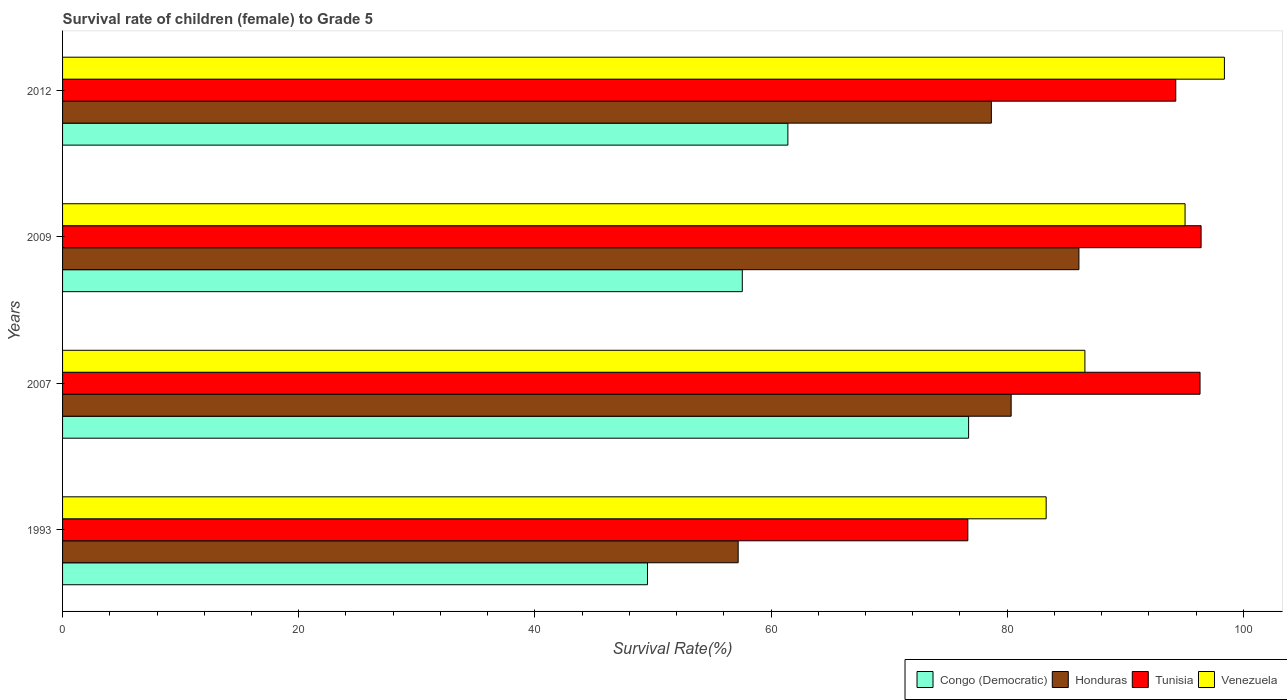How many bars are there on the 4th tick from the top?
Offer a very short reply. 4. What is the survival rate of female children to grade 5 in Venezuela in 1993?
Your response must be concise. 83.3. Across all years, what is the maximum survival rate of female children to grade 5 in Congo (Democratic)?
Ensure brevity in your answer.  76.73. Across all years, what is the minimum survival rate of female children to grade 5 in Tunisia?
Offer a very short reply. 76.67. In which year was the survival rate of female children to grade 5 in Congo (Democratic) minimum?
Ensure brevity in your answer.  1993. What is the total survival rate of female children to grade 5 in Tunisia in the graph?
Provide a succinct answer. 363.7. What is the difference between the survival rate of female children to grade 5 in Tunisia in 1993 and that in 2009?
Your answer should be compact. -19.76. What is the difference between the survival rate of female children to grade 5 in Tunisia in 2009 and the survival rate of female children to grade 5 in Venezuela in 2007?
Make the answer very short. 9.84. What is the average survival rate of female children to grade 5 in Venezuela per year?
Make the answer very short. 90.84. In the year 2007, what is the difference between the survival rate of female children to grade 5 in Venezuela and survival rate of female children to grade 5 in Honduras?
Offer a terse response. 6.25. In how many years, is the survival rate of female children to grade 5 in Honduras greater than 52 %?
Offer a very short reply. 4. What is the ratio of the survival rate of female children to grade 5 in Congo (Democratic) in 1993 to that in 2009?
Provide a succinct answer. 0.86. Is the survival rate of female children to grade 5 in Venezuela in 2009 less than that in 2012?
Keep it short and to the point. Yes. Is the difference between the survival rate of female children to grade 5 in Venezuela in 2007 and 2012 greater than the difference between the survival rate of female children to grade 5 in Honduras in 2007 and 2012?
Provide a short and direct response. No. What is the difference between the highest and the second highest survival rate of female children to grade 5 in Venezuela?
Provide a succinct answer. 3.33. What is the difference between the highest and the lowest survival rate of female children to grade 5 in Congo (Democratic)?
Offer a very short reply. 27.2. Is the sum of the survival rate of female children to grade 5 in Venezuela in 1993 and 2012 greater than the maximum survival rate of female children to grade 5 in Honduras across all years?
Make the answer very short. Yes. What does the 1st bar from the top in 2009 represents?
Provide a short and direct response. Venezuela. What does the 2nd bar from the bottom in 2009 represents?
Provide a succinct answer. Honduras. What is the difference between two consecutive major ticks on the X-axis?
Your response must be concise. 20. Are the values on the major ticks of X-axis written in scientific E-notation?
Your answer should be very brief. No. Does the graph contain any zero values?
Keep it short and to the point. No. Does the graph contain grids?
Keep it short and to the point. No. Where does the legend appear in the graph?
Offer a terse response. Bottom right. How many legend labels are there?
Offer a very short reply. 4. How are the legend labels stacked?
Give a very brief answer. Horizontal. What is the title of the graph?
Offer a terse response. Survival rate of children (female) to Grade 5. What is the label or title of the X-axis?
Provide a succinct answer. Survival Rate(%). What is the label or title of the Y-axis?
Your answer should be compact. Years. What is the Survival Rate(%) in Congo (Democratic) in 1993?
Provide a succinct answer. 49.54. What is the Survival Rate(%) in Honduras in 1993?
Your answer should be very brief. 57.22. What is the Survival Rate(%) of Tunisia in 1993?
Keep it short and to the point. 76.67. What is the Survival Rate(%) in Venezuela in 1993?
Make the answer very short. 83.3. What is the Survival Rate(%) of Congo (Democratic) in 2007?
Provide a succinct answer. 76.73. What is the Survival Rate(%) of Honduras in 2007?
Provide a succinct answer. 80.34. What is the Survival Rate(%) in Tunisia in 2007?
Offer a very short reply. 96.33. What is the Survival Rate(%) in Venezuela in 2007?
Provide a succinct answer. 86.58. What is the Survival Rate(%) in Congo (Democratic) in 2009?
Ensure brevity in your answer.  57.57. What is the Survival Rate(%) in Honduras in 2009?
Keep it short and to the point. 86.08. What is the Survival Rate(%) in Tunisia in 2009?
Your answer should be compact. 96.42. What is the Survival Rate(%) of Venezuela in 2009?
Your response must be concise. 95.07. What is the Survival Rate(%) of Congo (Democratic) in 2012?
Keep it short and to the point. 61.43. What is the Survival Rate(%) in Honduras in 2012?
Offer a very short reply. 78.66. What is the Survival Rate(%) in Tunisia in 2012?
Offer a terse response. 94.28. What is the Survival Rate(%) in Venezuela in 2012?
Your response must be concise. 98.4. Across all years, what is the maximum Survival Rate(%) in Congo (Democratic)?
Offer a terse response. 76.73. Across all years, what is the maximum Survival Rate(%) in Honduras?
Your response must be concise. 86.08. Across all years, what is the maximum Survival Rate(%) of Tunisia?
Your response must be concise. 96.42. Across all years, what is the maximum Survival Rate(%) of Venezuela?
Your answer should be compact. 98.4. Across all years, what is the minimum Survival Rate(%) in Congo (Democratic)?
Offer a very short reply. 49.54. Across all years, what is the minimum Survival Rate(%) of Honduras?
Ensure brevity in your answer.  57.22. Across all years, what is the minimum Survival Rate(%) of Tunisia?
Give a very brief answer. 76.67. Across all years, what is the minimum Survival Rate(%) of Venezuela?
Your response must be concise. 83.3. What is the total Survival Rate(%) in Congo (Democratic) in the graph?
Your response must be concise. 245.27. What is the total Survival Rate(%) in Honduras in the graph?
Provide a succinct answer. 302.29. What is the total Survival Rate(%) in Tunisia in the graph?
Make the answer very short. 363.7. What is the total Survival Rate(%) of Venezuela in the graph?
Ensure brevity in your answer.  363.35. What is the difference between the Survival Rate(%) in Congo (Democratic) in 1993 and that in 2007?
Give a very brief answer. -27.2. What is the difference between the Survival Rate(%) in Honduras in 1993 and that in 2007?
Make the answer very short. -23.12. What is the difference between the Survival Rate(%) of Tunisia in 1993 and that in 2007?
Offer a terse response. -19.67. What is the difference between the Survival Rate(%) of Venezuela in 1993 and that in 2007?
Keep it short and to the point. -3.28. What is the difference between the Survival Rate(%) in Congo (Democratic) in 1993 and that in 2009?
Your answer should be very brief. -8.03. What is the difference between the Survival Rate(%) of Honduras in 1993 and that in 2009?
Keep it short and to the point. -28.86. What is the difference between the Survival Rate(%) in Tunisia in 1993 and that in 2009?
Keep it short and to the point. -19.76. What is the difference between the Survival Rate(%) of Venezuela in 1993 and that in 2009?
Your response must be concise. -11.76. What is the difference between the Survival Rate(%) in Congo (Democratic) in 1993 and that in 2012?
Provide a succinct answer. -11.89. What is the difference between the Survival Rate(%) in Honduras in 1993 and that in 2012?
Offer a terse response. -21.44. What is the difference between the Survival Rate(%) in Tunisia in 1993 and that in 2012?
Provide a short and direct response. -17.61. What is the difference between the Survival Rate(%) in Venezuela in 1993 and that in 2012?
Offer a terse response. -15.1. What is the difference between the Survival Rate(%) of Congo (Democratic) in 2007 and that in 2009?
Your answer should be compact. 19.17. What is the difference between the Survival Rate(%) of Honduras in 2007 and that in 2009?
Offer a very short reply. -5.74. What is the difference between the Survival Rate(%) of Tunisia in 2007 and that in 2009?
Keep it short and to the point. -0.09. What is the difference between the Survival Rate(%) in Venezuela in 2007 and that in 2009?
Provide a succinct answer. -8.48. What is the difference between the Survival Rate(%) of Congo (Democratic) in 2007 and that in 2012?
Provide a short and direct response. 15.31. What is the difference between the Survival Rate(%) in Honduras in 2007 and that in 2012?
Provide a succinct answer. 1.68. What is the difference between the Survival Rate(%) of Tunisia in 2007 and that in 2012?
Provide a short and direct response. 2.06. What is the difference between the Survival Rate(%) of Venezuela in 2007 and that in 2012?
Make the answer very short. -11.81. What is the difference between the Survival Rate(%) of Congo (Democratic) in 2009 and that in 2012?
Offer a very short reply. -3.86. What is the difference between the Survival Rate(%) in Honduras in 2009 and that in 2012?
Keep it short and to the point. 7.42. What is the difference between the Survival Rate(%) of Tunisia in 2009 and that in 2012?
Your answer should be compact. 2.15. What is the difference between the Survival Rate(%) in Venezuela in 2009 and that in 2012?
Provide a succinct answer. -3.33. What is the difference between the Survival Rate(%) in Congo (Democratic) in 1993 and the Survival Rate(%) in Honduras in 2007?
Your response must be concise. -30.8. What is the difference between the Survival Rate(%) in Congo (Democratic) in 1993 and the Survival Rate(%) in Tunisia in 2007?
Offer a terse response. -46.8. What is the difference between the Survival Rate(%) of Congo (Democratic) in 1993 and the Survival Rate(%) of Venezuela in 2007?
Ensure brevity in your answer.  -37.05. What is the difference between the Survival Rate(%) of Honduras in 1993 and the Survival Rate(%) of Tunisia in 2007?
Offer a very short reply. -39.12. What is the difference between the Survival Rate(%) of Honduras in 1993 and the Survival Rate(%) of Venezuela in 2007?
Your answer should be compact. -29.37. What is the difference between the Survival Rate(%) in Tunisia in 1993 and the Survival Rate(%) in Venezuela in 2007?
Ensure brevity in your answer.  -9.92. What is the difference between the Survival Rate(%) of Congo (Democratic) in 1993 and the Survival Rate(%) of Honduras in 2009?
Offer a terse response. -36.54. What is the difference between the Survival Rate(%) in Congo (Democratic) in 1993 and the Survival Rate(%) in Tunisia in 2009?
Your answer should be compact. -46.89. What is the difference between the Survival Rate(%) of Congo (Democratic) in 1993 and the Survival Rate(%) of Venezuela in 2009?
Give a very brief answer. -45.53. What is the difference between the Survival Rate(%) in Honduras in 1993 and the Survival Rate(%) in Tunisia in 2009?
Your answer should be very brief. -39.21. What is the difference between the Survival Rate(%) in Honduras in 1993 and the Survival Rate(%) in Venezuela in 2009?
Your answer should be compact. -37.85. What is the difference between the Survival Rate(%) in Tunisia in 1993 and the Survival Rate(%) in Venezuela in 2009?
Make the answer very short. -18.4. What is the difference between the Survival Rate(%) in Congo (Democratic) in 1993 and the Survival Rate(%) in Honduras in 2012?
Provide a short and direct response. -29.12. What is the difference between the Survival Rate(%) of Congo (Democratic) in 1993 and the Survival Rate(%) of Tunisia in 2012?
Keep it short and to the point. -44.74. What is the difference between the Survival Rate(%) in Congo (Democratic) in 1993 and the Survival Rate(%) in Venezuela in 2012?
Offer a very short reply. -48.86. What is the difference between the Survival Rate(%) of Honduras in 1993 and the Survival Rate(%) of Tunisia in 2012?
Keep it short and to the point. -37.06. What is the difference between the Survival Rate(%) of Honduras in 1993 and the Survival Rate(%) of Venezuela in 2012?
Provide a short and direct response. -41.18. What is the difference between the Survival Rate(%) of Tunisia in 1993 and the Survival Rate(%) of Venezuela in 2012?
Keep it short and to the point. -21.73. What is the difference between the Survival Rate(%) of Congo (Democratic) in 2007 and the Survival Rate(%) of Honduras in 2009?
Give a very brief answer. -9.34. What is the difference between the Survival Rate(%) of Congo (Democratic) in 2007 and the Survival Rate(%) of Tunisia in 2009?
Offer a terse response. -19.69. What is the difference between the Survival Rate(%) in Congo (Democratic) in 2007 and the Survival Rate(%) in Venezuela in 2009?
Make the answer very short. -18.33. What is the difference between the Survival Rate(%) of Honduras in 2007 and the Survival Rate(%) of Tunisia in 2009?
Keep it short and to the point. -16.09. What is the difference between the Survival Rate(%) in Honduras in 2007 and the Survival Rate(%) in Venezuela in 2009?
Provide a short and direct response. -14.73. What is the difference between the Survival Rate(%) of Tunisia in 2007 and the Survival Rate(%) of Venezuela in 2009?
Your answer should be very brief. 1.27. What is the difference between the Survival Rate(%) in Congo (Democratic) in 2007 and the Survival Rate(%) in Honduras in 2012?
Offer a very short reply. -1.93. What is the difference between the Survival Rate(%) in Congo (Democratic) in 2007 and the Survival Rate(%) in Tunisia in 2012?
Your answer should be very brief. -17.54. What is the difference between the Survival Rate(%) of Congo (Democratic) in 2007 and the Survival Rate(%) of Venezuela in 2012?
Make the answer very short. -21.66. What is the difference between the Survival Rate(%) of Honduras in 2007 and the Survival Rate(%) of Tunisia in 2012?
Ensure brevity in your answer.  -13.94. What is the difference between the Survival Rate(%) of Honduras in 2007 and the Survival Rate(%) of Venezuela in 2012?
Provide a succinct answer. -18.06. What is the difference between the Survival Rate(%) in Tunisia in 2007 and the Survival Rate(%) in Venezuela in 2012?
Make the answer very short. -2.06. What is the difference between the Survival Rate(%) of Congo (Democratic) in 2009 and the Survival Rate(%) of Honduras in 2012?
Make the answer very short. -21.09. What is the difference between the Survival Rate(%) in Congo (Democratic) in 2009 and the Survival Rate(%) in Tunisia in 2012?
Keep it short and to the point. -36.71. What is the difference between the Survival Rate(%) of Congo (Democratic) in 2009 and the Survival Rate(%) of Venezuela in 2012?
Ensure brevity in your answer.  -40.83. What is the difference between the Survival Rate(%) of Honduras in 2009 and the Survival Rate(%) of Tunisia in 2012?
Your answer should be compact. -8.2. What is the difference between the Survival Rate(%) in Honduras in 2009 and the Survival Rate(%) in Venezuela in 2012?
Your answer should be compact. -12.32. What is the difference between the Survival Rate(%) in Tunisia in 2009 and the Survival Rate(%) in Venezuela in 2012?
Your response must be concise. -1.97. What is the average Survival Rate(%) in Congo (Democratic) per year?
Provide a succinct answer. 61.32. What is the average Survival Rate(%) in Honduras per year?
Give a very brief answer. 75.57. What is the average Survival Rate(%) in Tunisia per year?
Give a very brief answer. 90.93. What is the average Survival Rate(%) in Venezuela per year?
Your answer should be compact. 90.84. In the year 1993, what is the difference between the Survival Rate(%) in Congo (Democratic) and Survival Rate(%) in Honduras?
Ensure brevity in your answer.  -7.68. In the year 1993, what is the difference between the Survival Rate(%) in Congo (Democratic) and Survival Rate(%) in Tunisia?
Keep it short and to the point. -27.13. In the year 1993, what is the difference between the Survival Rate(%) in Congo (Democratic) and Survival Rate(%) in Venezuela?
Ensure brevity in your answer.  -33.76. In the year 1993, what is the difference between the Survival Rate(%) of Honduras and Survival Rate(%) of Tunisia?
Offer a very short reply. -19.45. In the year 1993, what is the difference between the Survival Rate(%) in Honduras and Survival Rate(%) in Venezuela?
Your answer should be compact. -26.08. In the year 1993, what is the difference between the Survival Rate(%) in Tunisia and Survival Rate(%) in Venezuela?
Keep it short and to the point. -6.63. In the year 2007, what is the difference between the Survival Rate(%) of Congo (Democratic) and Survival Rate(%) of Honduras?
Offer a terse response. -3.6. In the year 2007, what is the difference between the Survival Rate(%) in Congo (Democratic) and Survival Rate(%) in Tunisia?
Give a very brief answer. -19.6. In the year 2007, what is the difference between the Survival Rate(%) in Congo (Democratic) and Survival Rate(%) in Venezuela?
Your answer should be very brief. -9.85. In the year 2007, what is the difference between the Survival Rate(%) in Honduras and Survival Rate(%) in Tunisia?
Provide a short and direct response. -16. In the year 2007, what is the difference between the Survival Rate(%) of Honduras and Survival Rate(%) of Venezuela?
Keep it short and to the point. -6.25. In the year 2007, what is the difference between the Survival Rate(%) of Tunisia and Survival Rate(%) of Venezuela?
Provide a short and direct response. 9.75. In the year 2009, what is the difference between the Survival Rate(%) of Congo (Democratic) and Survival Rate(%) of Honduras?
Make the answer very short. -28.51. In the year 2009, what is the difference between the Survival Rate(%) in Congo (Democratic) and Survival Rate(%) in Tunisia?
Keep it short and to the point. -38.86. In the year 2009, what is the difference between the Survival Rate(%) of Congo (Democratic) and Survival Rate(%) of Venezuela?
Your answer should be compact. -37.5. In the year 2009, what is the difference between the Survival Rate(%) in Honduras and Survival Rate(%) in Tunisia?
Provide a short and direct response. -10.35. In the year 2009, what is the difference between the Survival Rate(%) of Honduras and Survival Rate(%) of Venezuela?
Make the answer very short. -8.99. In the year 2009, what is the difference between the Survival Rate(%) in Tunisia and Survival Rate(%) in Venezuela?
Your answer should be compact. 1.36. In the year 2012, what is the difference between the Survival Rate(%) in Congo (Democratic) and Survival Rate(%) in Honduras?
Give a very brief answer. -17.23. In the year 2012, what is the difference between the Survival Rate(%) of Congo (Democratic) and Survival Rate(%) of Tunisia?
Your response must be concise. -32.85. In the year 2012, what is the difference between the Survival Rate(%) of Congo (Democratic) and Survival Rate(%) of Venezuela?
Provide a short and direct response. -36.97. In the year 2012, what is the difference between the Survival Rate(%) of Honduras and Survival Rate(%) of Tunisia?
Your response must be concise. -15.62. In the year 2012, what is the difference between the Survival Rate(%) of Honduras and Survival Rate(%) of Venezuela?
Give a very brief answer. -19.74. In the year 2012, what is the difference between the Survival Rate(%) in Tunisia and Survival Rate(%) in Venezuela?
Provide a succinct answer. -4.12. What is the ratio of the Survival Rate(%) of Congo (Democratic) in 1993 to that in 2007?
Provide a succinct answer. 0.65. What is the ratio of the Survival Rate(%) in Honduras in 1993 to that in 2007?
Keep it short and to the point. 0.71. What is the ratio of the Survival Rate(%) of Tunisia in 1993 to that in 2007?
Offer a terse response. 0.8. What is the ratio of the Survival Rate(%) of Venezuela in 1993 to that in 2007?
Ensure brevity in your answer.  0.96. What is the ratio of the Survival Rate(%) of Congo (Democratic) in 1993 to that in 2009?
Provide a short and direct response. 0.86. What is the ratio of the Survival Rate(%) of Honduras in 1993 to that in 2009?
Give a very brief answer. 0.66. What is the ratio of the Survival Rate(%) in Tunisia in 1993 to that in 2009?
Provide a short and direct response. 0.8. What is the ratio of the Survival Rate(%) in Venezuela in 1993 to that in 2009?
Your response must be concise. 0.88. What is the ratio of the Survival Rate(%) of Congo (Democratic) in 1993 to that in 2012?
Give a very brief answer. 0.81. What is the ratio of the Survival Rate(%) in Honduras in 1993 to that in 2012?
Your answer should be compact. 0.73. What is the ratio of the Survival Rate(%) of Tunisia in 1993 to that in 2012?
Make the answer very short. 0.81. What is the ratio of the Survival Rate(%) of Venezuela in 1993 to that in 2012?
Ensure brevity in your answer.  0.85. What is the ratio of the Survival Rate(%) of Congo (Democratic) in 2007 to that in 2009?
Give a very brief answer. 1.33. What is the ratio of the Survival Rate(%) of Honduras in 2007 to that in 2009?
Make the answer very short. 0.93. What is the ratio of the Survival Rate(%) in Tunisia in 2007 to that in 2009?
Your answer should be compact. 1. What is the ratio of the Survival Rate(%) in Venezuela in 2007 to that in 2009?
Provide a succinct answer. 0.91. What is the ratio of the Survival Rate(%) of Congo (Democratic) in 2007 to that in 2012?
Provide a succinct answer. 1.25. What is the ratio of the Survival Rate(%) of Honduras in 2007 to that in 2012?
Offer a terse response. 1.02. What is the ratio of the Survival Rate(%) in Tunisia in 2007 to that in 2012?
Give a very brief answer. 1.02. What is the ratio of the Survival Rate(%) of Venezuela in 2007 to that in 2012?
Offer a terse response. 0.88. What is the ratio of the Survival Rate(%) of Congo (Democratic) in 2009 to that in 2012?
Offer a terse response. 0.94. What is the ratio of the Survival Rate(%) in Honduras in 2009 to that in 2012?
Your answer should be compact. 1.09. What is the ratio of the Survival Rate(%) of Tunisia in 2009 to that in 2012?
Ensure brevity in your answer.  1.02. What is the ratio of the Survival Rate(%) of Venezuela in 2009 to that in 2012?
Your response must be concise. 0.97. What is the difference between the highest and the second highest Survival Rate(%) in Congo (Democratic)?
Provide a succinct answer. 15.31. What is the difference between the highest and the second highest Survival Rate(%) in Honduras?
Keep it short and to the point. 5.74. What is the difference between the highest and the second highest Survival Rate(%) of Tunisia?
Keep it short and to the point. 0.09. What is the difference between the highest and the second highest Survival Rate(%) in Venezuela?
Offer a very short reply. 3.33. What is the difference between the highest and the lowest Survival Rate(%) of Congo (Democratic)?
Your answer should be very brief. 27.2. What is the difference between the highest and the lowest Survival Rate(%) of Honduras?
Your response must be concise. 28.86. What is the difference between the highest and the lowest Survival Rate(%) in Tunisia?
Ensure brevity in your answer.  19.76. What is the difference between the highest and the lowest Survival Rate(%) of Venezuela?
Offer a very short reply. 15.1. 